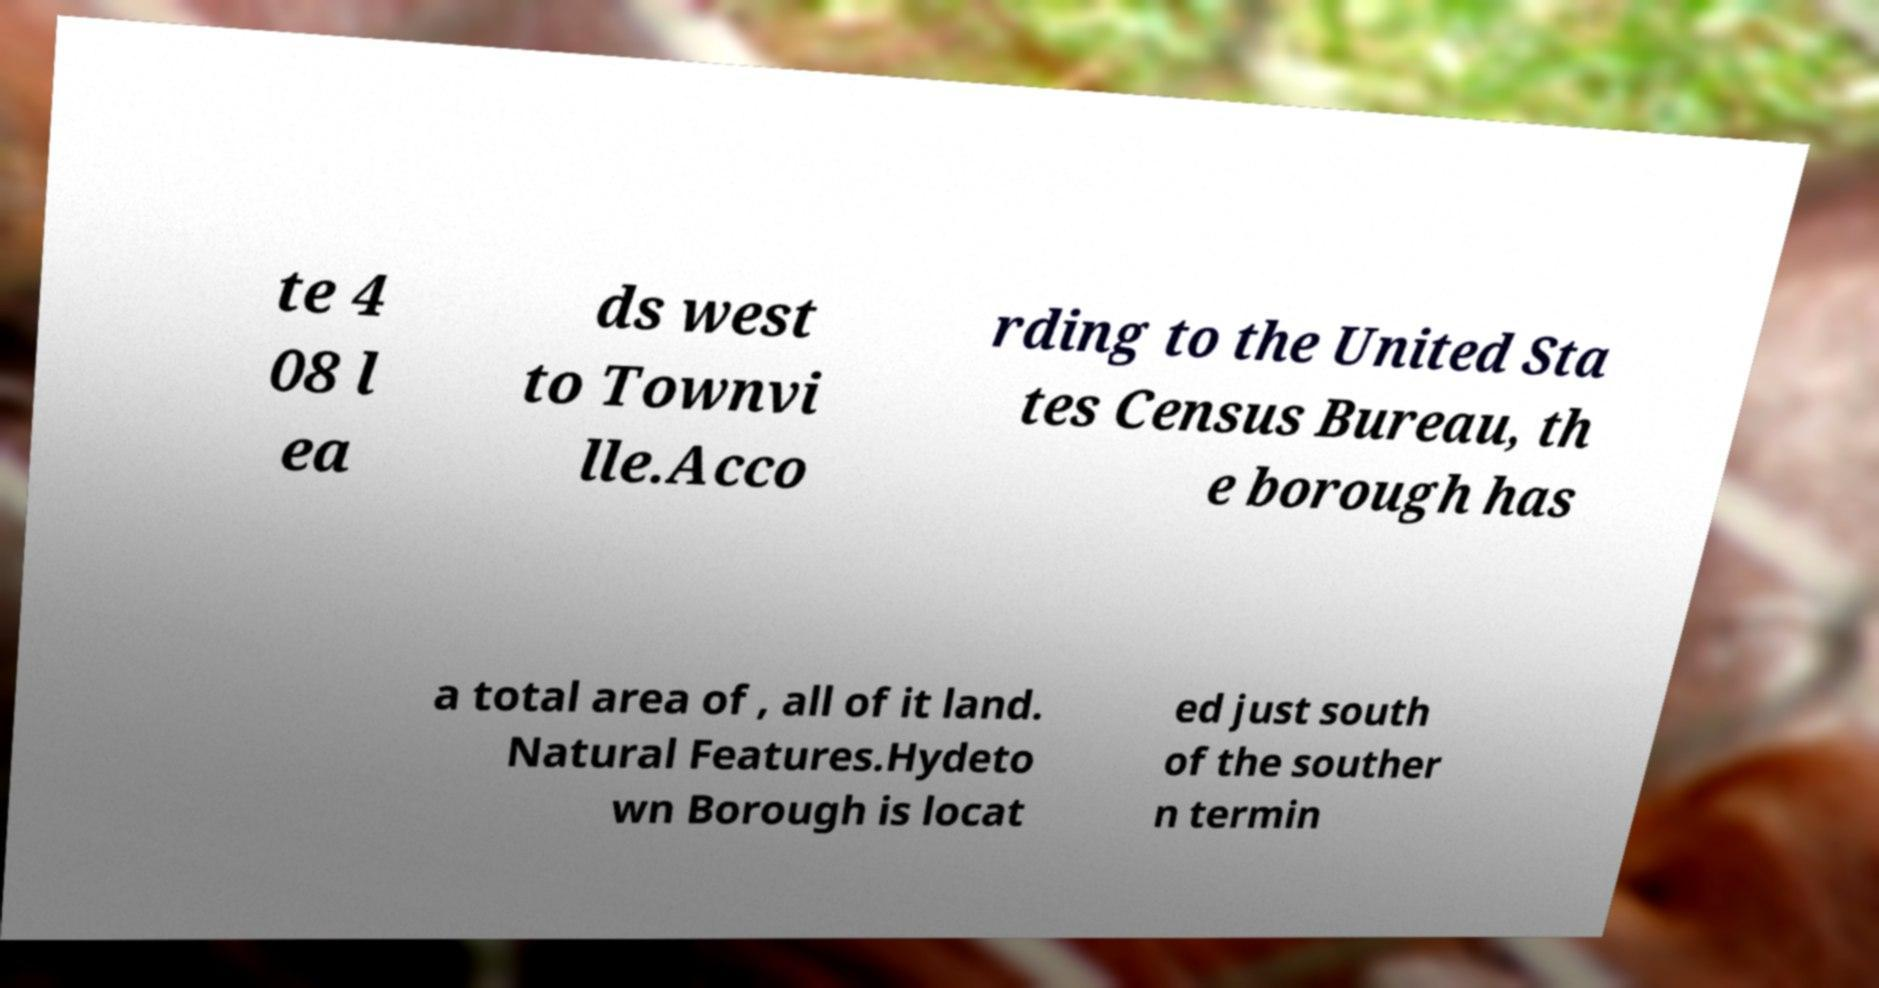Can you accurately transcribe the text from the provided image for me? te 4 08 l ea ds west to Townvi lle.Acco rding to the United Sta tes Census Bureau, th e borough has a total area of , all of it land. Natural Features.Hydeto wn Borough is locat ed just south of the souther n termin 